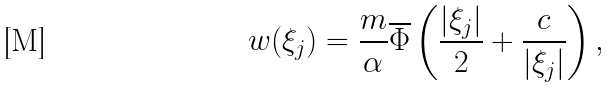<formula> <loc_0><loc_0><loc_500><loc_500>w ( \xi _ { j } ) = \frac { m } { \alpha } \overline { \Phi } \left ( \frac { | \xi _ { j } | } { 2 } + \frac { c } { | \xi _ { j } | } \right ) ,</formula> 